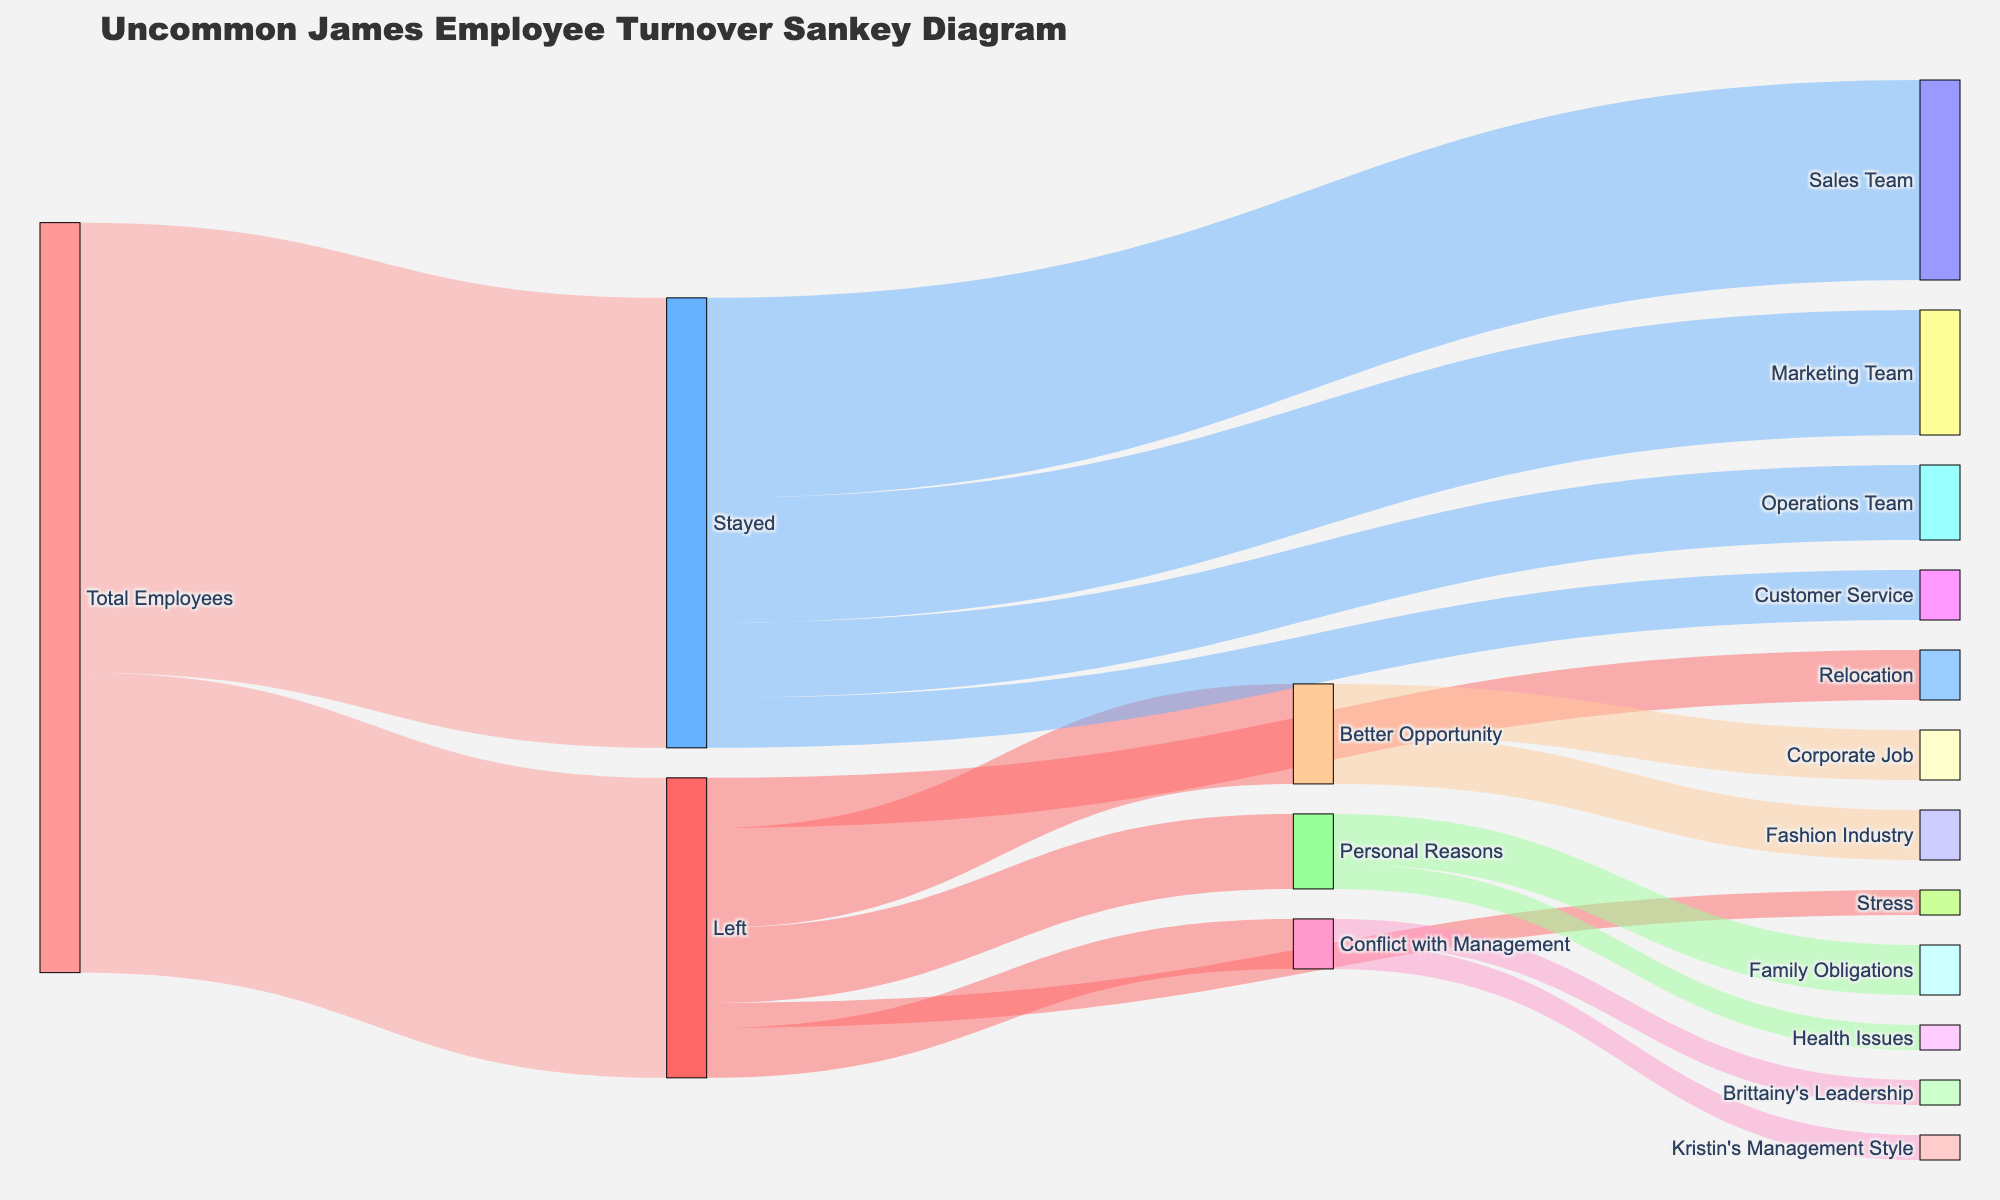What's the title of the diagram? The title is generally placed at the top of the figure. Just by looking at the top section of the diagram, you can see the title text displayed.
Answer: Uncommon James Employee Turnover Sankey Diagram What is the total number of employees at Uncommon James? The total number of employees can be identified from the "Total Employees" source node. According to the figure, this node shows a flow leading to both "Stayed" and "Left". Adding these values gives us the total number.
Answer: 30 How many employees stayed at the company? The number of employees who stayed is shown coming out of the "Total Employees" node towards the "Stayed" node. Simply refer to the value indicated on that path.
Answer: 18 What are the most common reasons employees left Uncommon James? To find the most common reasons, look at all the flows coming from the "Left" node and compare their values. The biggest value indicates the most common reason.
Answer: Better Opportunity Which team has the fewest employees staying? Check all the flows coming from the "Stayed" node toward various team nodes. The team with the smallest flow represents the team with the fewest staying employees.
Answer: Customer Service How many employees left for a better opportunity in a fashion industry? Focus on the "Better Opportunity" node that splits into sub-reasons. Identify the flow that goes into the "Fashion Industry" node and read the value assigned to it.
Answer: 2 What's the difference in the number of employees who left for better opportunities versus personal reasons? First, get the numbers for employees who left for better opportunities and those who left for personal reasons from the "Better Opportunity" and "Personal Reasons" nodes, respectively. Then, subtract the smaller number from the larger one.
Answer: 1 Compare the number of employees who stayed in the Sales Team versus the Marketing Team. Look at the specific paths coming from the "Stayed" node and leading to "Sales Team" and "Marketing Team." Compare the values of these respective paths.
Answer: Sales Team: 8, Marketing Team: 5 How many employees left due to conflict with management? Sum up all the values flowing from the "Conflict with Management" node to its sub-reasons.
Answer: 2 Which reasons contributed to employees leaving under 'Conflict with Management'? Track the flows that stem from the "Conflict with Management" node. Each flow leads to a sub-reason which you can identify and count.
Answer: Kristin's Management Style, Brittainy's Leadership 